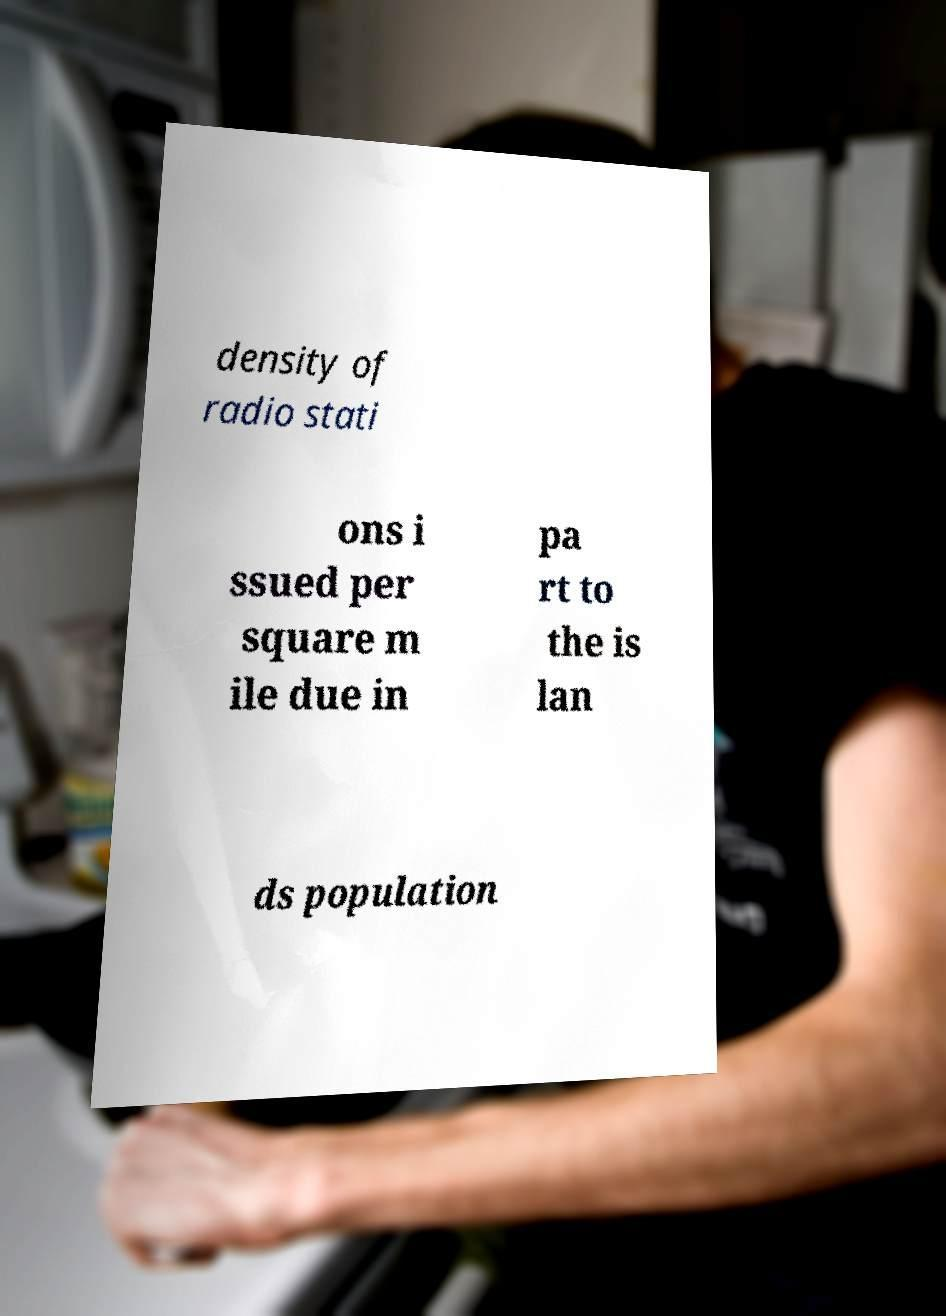What messages or text are displayed in this image? I need them in a readable, typed format. density of radio stati ons i ssued per square m ile due in pa rt to the is lan ds population 